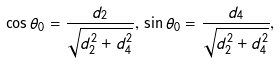Convert formula to latex. <formula><loc_0><loc_0><loc_500><loc_500>\cos \theta _ { 0 } = \frac { d _ { 2 } } { \sqrt { d _ { 2 } ^ { 2 } + d _ { 4 } ^ { 2 } } } , \, \sin \theta _ { 0 } = \frac { d _ { 4 } } { \sqrt { d _ { 2 } ^ { 2 } + d _ { 4 } ^ { 2 } } } ,</formula> 